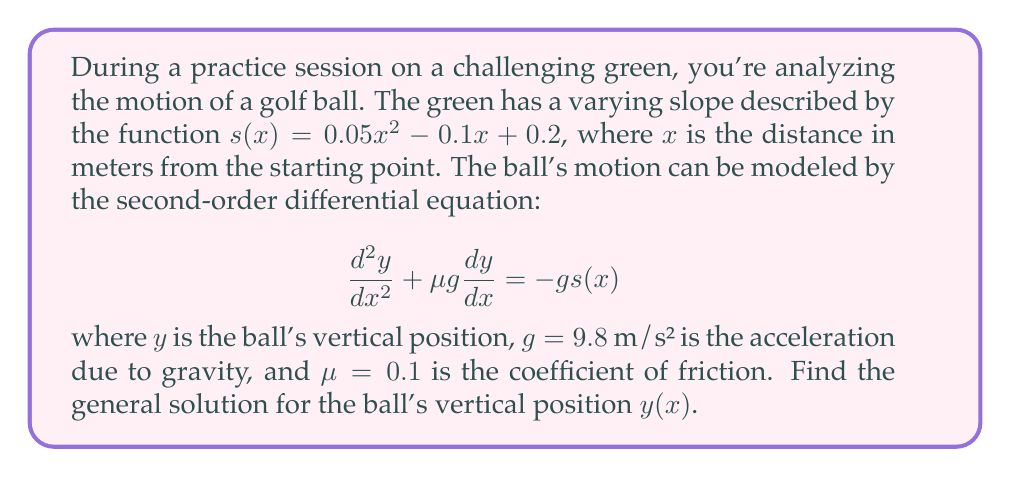Help me with this question. Let's solve this step-by-step:

1) First, we substitute the given slope function into the differential equation:

   $$\frac{d^2y}{dx^2} + \mu g \frac{dy}{dx} = -g (0.05x^2 - 0.1x + 0.2)$$

2) Simplify the right-hand side:

   $$\frac{d^2y}{dx^2} + \mu g \frac{dy}{dx} = -0.49x^2 + 0.98x - 1.96$$

3) This is a non-homogeneous linear differential equation. We need to find the general solution of the homogeneous equation and a particular solution of the non-homogeneous equation.

4) The homogeneous equation is:

   $$\frac{d^2y}{dx^2} + \mu g \frac{dy}{dx} = 0$$

5) The characteristic equation is:

   $$r^2 + \mu g r = 0$$

   $$r(r + \mu g) = 0$$

6) The roots are $r_1 = 0$ and $r_2 = -\mu g = -0.98$

7) The general solution of the homogeneous equation is:

   $$y_h(x) = C_1 + C_2e^{-0.98x}$$

8) For the particular solution, we use the method of undetermined coefficients. We guess a solution of the form:

   $$y_p(x) = Ax^2 + Bx + D$$

9) Substitute this into the original equation and equate coefficients:

   $$2A + \mu g (2Ax + B) = -0.49x^2 + 0.98x - 1.96$$

10) Equating coefficients:

    $x^2: 2A\mu g = -0.49$
    $x: 2A + B\mu g = 0.98$
    constant: $2A + B\mu g = -1.96$

11) Solving this system:

    $A = -0.25$
    $B = 0.51$
    $D = -1$

12) Therefore, the particular solution is:

    $$y_p(x) = -0.25x^2 + 0.51x - 1$$

13) The general solution is the sum of the homogeneous and particular solutions:

    $$y(x) = y_h(x) + y_p(x) = C_1 + C_2e^{-0.98x} - 0.25x^2 + 0.51x - 1$$
Answer: $y(x) = C_1 + C_2e^{-0.98x} - 0.25x^2 + 0.51x - 1$ 